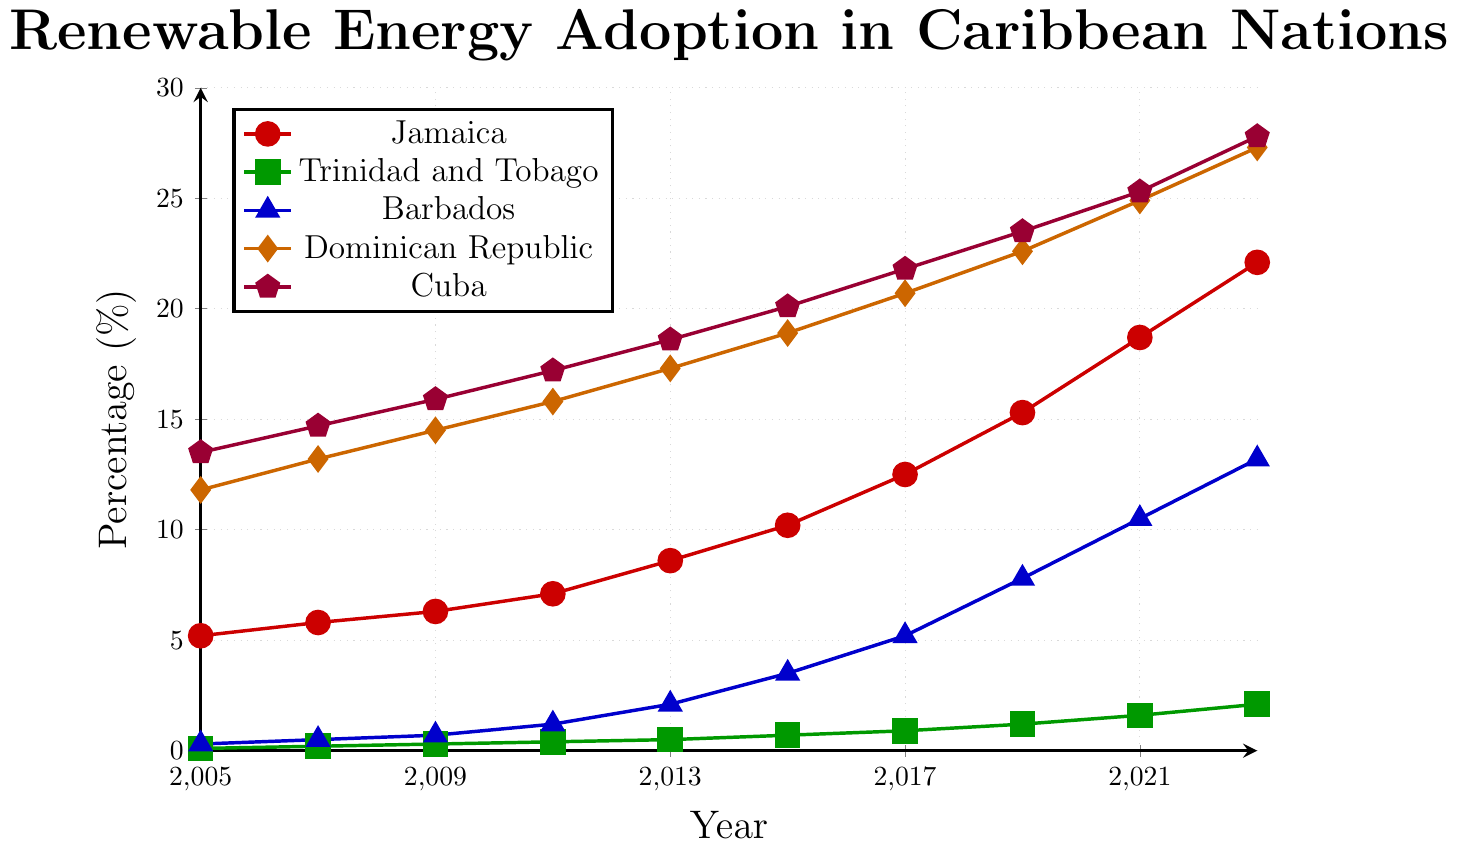What year did Cuba surpass 20% renewable energy adoption? To determine when Cuba's renewable energy adoption rate exceeded 20%, refer to the point where the line representing Cuba crosses the 20% mark. According to the figure, this occurs between 2013 (18.6%) and 2015 (20.1%).
Answer: 2015 Between which years did Jamaica see the highest increase in renewable energy adoption? To find the period with the highest increase in Jamaica’s renewable energy adoption, examine the slope of the line representing Jamaica and identify the years with the steepest incline. The figure shows that the biggest jump is from 2019 (15.3%) to 2021 (18.7%).
Answer: 2019-2021 Which country had the lowest renewable energy adoption rate in 2023? Identify the data point in 2023 for each country and compare the values. The country with the smallest value indicates the lowest adoption rate. According to the figure, Trinidad and Tobago had the lowest rate at 2.1%.
Answer: Trinidad and Tobago What is the average renewable energy adoption rate in Barbados over the years provided? To calculate the average, add up all the percentages for Barbados and divide by the number of years. The values are 0.3, 0.5, 0.7, 1.2, 2.1, 3.5, 5.2, 7.8, 10.5, and 13.2. The sum is 45.0, dividing by 10 gives 4.5.
Answer: 4.5% How much did Trinidad and Tobago’s renewable energy adoption increase from 2005 to 2023? Subtract the adoption rate in 2005 (0.1%) from that in 2023 (2.1%) for Trinidad and Tobago to find the increase. 2.1% - 0.1% = 2.0%.
Answer: 2.0% Which country had a higher renewable energy adoption rate in 2015, Dominican Republic or Cuba? Compare the values for 2015 for Dominican Republic and Cuba. Dominican Republic had 18.9% while Cuba had 20.1%. Thus, Cuba had the higher rate.
Answer: Cuba What is the difference in renewable energy adoption between Jamaica and Barbados in 2023? Subtract the value for Barbados (13.2%) from that of Jamaica (22.1%) in 2023. 22.1% - 13.2% = 8.9%.
Answer: 8.9% In which year did Dominican Republic and Cuba have nearly the same renewable energy adoption rate? Identify the closest values for Dominican Republic and Cuba. In 2017, Dominican Republic had 20.7% and Cuba had 21.8%, which is a close comparison.
Answer: 2017 In 2021, how did the renewable energy adoption rate of Barbados compare proportionally to that of Trinidad and Tobago? Divide Barbados’s adoption rate (10.5%) by Trinidad and Tobago’s rate (1.6%) in 2021. 10.5 / 1.6 = 6.56. Therefore, Barbados's rate was approximately 6.56 times that of Trinidad and Tobago.
Answer: About 6.56 times What is the combined renewable energy adoption rate of Dominican Republic and Cuba in 2019? Add the adoption rates of Dominican Republic (22.6%) and Cuba (23.5%) for 2019. 22.6% + 23.5% = 46.1%.
Answer: 46.1% 